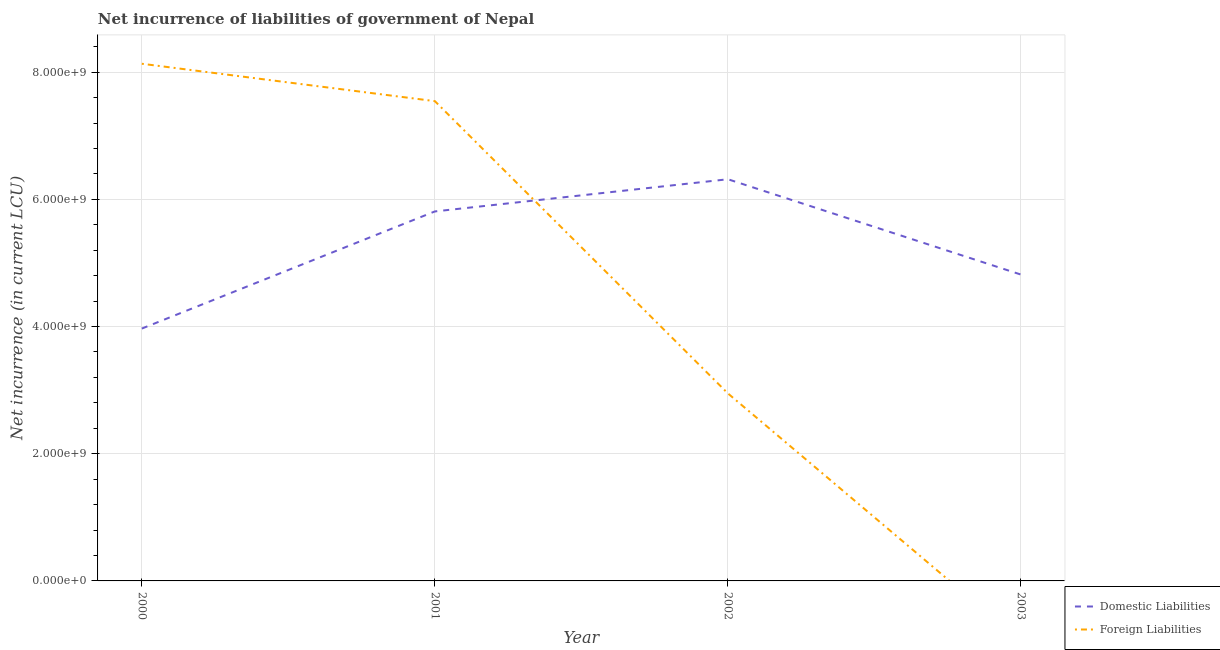How many different coloured lines are there?
Provide a succinct answer. 2. Does the line corresponding to net incurrence of domestic liabilities intersect with the line corresponding to net incurrence of foreign liabilities?
Provide a short and direct response. Yes. What is the net incurrence of foreign liabilities in 2003?
Offer a very short reply. 0. Across all years, what is the maximum net incurrence of domestic liabilities?
Keep it short and to the point. 6.32e+09. Across all years, what is the minimum net incurrence of domestic liabilities?
Your response must be concise. 3.97e+09. In which year was the net incurrence of foreign liabilities maximum?
Offer a terse response. 2000. What is the total net incurrence of domestic liabilities in the graph?
Your answer should be compact. 2.09e+1. What is the difference between the net incurrence of foreign liabilities in 2000 and that in 2001?
Make the answer very short. 5.88e+08. What is the difference between the net incurrence of foreign liabilities in 2002 and the net incurrence of domestic liabilities in 2001?
Provide a succinct answer. -2.86e+09. What is the average net incurrence of foreign liabilities per year?
Ensure brevity in your answer.  4.66e+09. In the year 2001, what is the difference between the net incurrence of foreign liabilities and net incurrence of domestic liabilities?
Provide a short and direct response. 1.73e+09. What is the ratio of the net incurrence of foreign liabilities in 2000 to that in 2002?
Your response must be concise. 2.76. Is the difference between the net incurrence of domestic liabilities in 2000 and 2002 greater than the difference between the net incurrence of foreign liabilities in 2000 and 2002?
Offer a terse response. No. What is the difference between the highest and the second highest net incurrence of foreign liabilities?
Offer a terse response. 5.88e+08. What is the difference between the highest and the lowest net incurrence of foreign liabilities?
Your answer should be compact. 8.13e+09. Is the net incurrence of foreign liabilities strictly greater than the net incurrence of domestic liabilities over the years?
Make the answer very short. No. Is the net incurrence of domestic liabilities strictly less than the net incurrence of foreign liabilities over the years?
Your answer should be compact. No. How many years are there in the graph?
Ensure brevity in your answer.  4. What is the difference between two consecutive major ticks on the Y-axis?
Provide a short and direct response. 2.00e+09. Does the graph contain any zero values?
Make the answer very short. Yes. How are the legend labels stacked?
Your answer should be compact. Vertical. What is the title of the graph?
Provide a succinct answer. Net incurrence of liabilities of government of Nepal. What is the label or title of the X-axis?
Your response must be concise. Year. What is the label or title of the Y-axis?
Make the answer very short. Net incurrence (in current LCU). What is the Net incurrence (in current LCU) in Domestic Liabilities in 2000?
Give a very brief answer. 3.97e+09. What is the Net incurrence (in current LCU) in Foreign Liabilities in 2000?
Provide a short and direct response. 8.13e+09. What is the Net incurrence (in current LCU) in Domestic Liabilities in 2001?
Offer a terse response. 5.81e+09. What is the Net incurrence (in current LCU) of Foreign Liabilities in 2001?
Make the answer very short. 7.54e+09. What is the Net incurrence (in current LCU) of Domestic Liabilities in 2002?
Your answer should be compact. 6.32e+09. What is the Net incurrence (in current LCU) in Foreign Liabilities in 2002?
Offer a terse response. 2.95e+09. What is the Net incurrence (in current LCU) of Domestic Liabilities in 2003?
Ensure brevity in your answer.  4.82e+09. What is the Net incurrence (in current LCU) of Foreign Liabilities in 2003?
Make the answer very short. 0. Across all years, what is the maximum Net incurrence (in current LCU) of Domestic Liabilities?
Your answer should be compact. 6.32e+09. Across all years, what is the maximum Net incurrence (in current LCU) in Foreign Liabilities?
Offer a very short reply. 8.13e+09. Across all years, what is the minimum Net incurrence (in current LCU) of Domestic Liabilities?
Offer a terse response. 3.97e+09. What is the total Net incurrence (in current LCU) of Domestic Liabilities in the graph?
Your response must be concise. 2.09e+1. What is the total Net incurrence (in current LCU) of Foreign Liabilities in the graph?
Give a very brief answer. 1.86e+1. What is the difference between the Net incurrence (in current LCU) of Domestic Liabilities in 2000 and that in 2001?
Offer a very short reply. -1.84e+09. What is the difference between the Net incurrence (in current LCU) in Foreign Liabilities in 2000 and that in 2001?
Your response must be concise. 5.88e+08. What is the difference between the Net incurrence (in current LCU) in Domestic Liabilities in 2000 and that in 2002?
Your response must be concise. -2.35e+09. What is the difference between the Net incurrence (in current LCU) of Foreign Liabilities in 2000 and that in 2002?
Give a very brief answer. 5.18e+09. What is the difference between the Net incurrence (in current LCU) in Domestic Liabilities in 2000 and that in 2003?
Offer a very short reply. -8.49e+08. What is the difference between the Net incurrence (in current LCU) of Domestic Liabilities in 2001 and that in 2002?
Provide a short and direct response. -5.06e+08. What is the difference between the Net incurrence (in current LCU) of Foreign Liabilities in 2001 and that in 2002?
Offer a very short reply. 4.60e+09. What is the difference between the Net incurrence (in current LCU) in Domestic Liabilities in 2001 and that in 2003?
Give a very brief answer. 9.93e+08. What is the difference between the Net incurrence (in current LCU) of Domestic Liabilities in 2002 and that in 2003?
Your response must be concise. 1.50e+09. What is the difference between the Net incurrence (in current LCU) in Domestic Liabilities in 2000 and the Net incurrence (in current LCU) in Foreign Liabilities in 2001?
Make the answer very short. -3.58e+09. What is the difference between the Net incurrence (in current LCU) of Domestic Liabilities in 2000 and the Net incurrence (in current LCU) of Foreign Liabilities in 2002?
Offer a terse response. 1.02e+09. What is the difference between the Net incurrence (in current LCU) in Domestic Liabilities in 2001 and the Net incurrence (in current LCU) in Foreign Liabilities in 2002?
Keep it short and to the point. 2.86e+09. What is the average Net incurrence (in current LCU) in Domestic Liabilities per year?
Give a very brief answer. 5.23e+09. What is the average Net incurrence (in current LCU) of Foreign Liabilities per year?
Give a very brief answer. 4.66e+09. In the year 2000, what is the difference between the Net incurrence (in current LCU) of Domestic Liabilities and Net incurrence (in current LCU) of Foreign Liabilities?
Offer a very short reply. -4.16e+09. In the year 2001, what is the difference between the Net incurrence (in current LCU) in Domestic Liabilities and Net incurrence (in current LCU) in Foreign Liabilities?
Provide a succinct answer. -1.73e+09. In the year 2002, what is the difference between the Net incurrence (in current LCU) of Domestic Liabilities and Net incurrence (in current LCU) of Foreign Liabilities?
Provide a short and direct response. 3.37e+09. What is the ratio of the Net incurrence (in current LCU) of Domestic Liabilities in 2000 to that in 2001?
Keep it short and to the point. 0.68. What is the ratio of the Net incurrence (in current LCU) in Foreign Liabilities in 2000 to that in 2001?
Offer a terse response. 1.08. What is the ratio of the Net incurrence (in current LCU) in Domestic Liabilities in 2000 to that in 2002?
Provide a succinct answer. 0.63. What is the ratio of the Net incurrence (in current LCU) of Foreign Liabilities in 2000 to that in 2002?
Make the answer very short. 2.76. What is the ratio of the Net incurrence (in current LCU) in Domestic Liabilities in 2000 to that in 2003?
Your answer should be compact. 0.82. What is the ratio of the Net incurrence (in current LCU) in Domestic Liabilities in 2001 to that in 2002?
Make the answer very short. 0.92. What is the ratio of the Net incurrence (in current LCU) in Foreign Liabilities in 2001 to that in 2002?
Provide a short and direct response. 2.56. What is the ratio of the Net incurrence (in current LCU) of Domestic Liabilities in 2001 to that in 2003?
Your answer should be very brief. 1.21. What is the ratio of the Net incurrence (in current LCU) in Domestic Liabilities in 2002 to that in 2003?
Provide a short and direct response. 1.31. What is the difference between the highest and the second highest Net incurrence (in current LCU) of Domestic Liabilities?
Ensure brevity in your answer.  5.06e+08. What is the difference between the highest and the second highest Net incurrence (in current LCU) of Foreign Liabilities?
Make the answer very short. 5.88e+08. What is the difference between the highest and the lowest Net incurrence (in current LCU) in Domestic Liabilities?
Ensure brevity in your answer.  2.35e+09. What is the difference between the highest and the lowest Net incurrence (in current LCU) in Foreign Liabilities?
Your answer should be compact. 8.13e+09. 